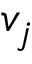Convert formula to latex. <formula><loc_0><loc_0><loc_500><loc_500>v _ { j }</formula> 